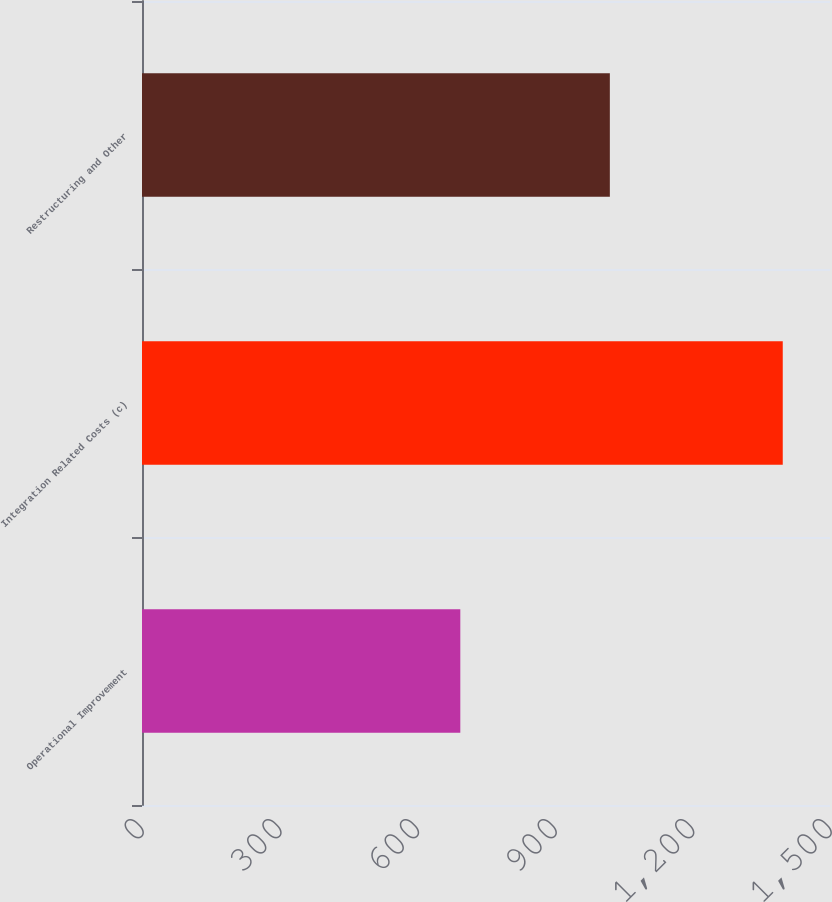<chart> <loc_0><loc_0><loc_500><loc_500><bar_chart><fcel>Operational Improvement<fcel>Integration Related Costs (c)<fcel>Restructuring and Other<nl><fcel>694<fcel>1397<fcel>1020<nl></chart> 